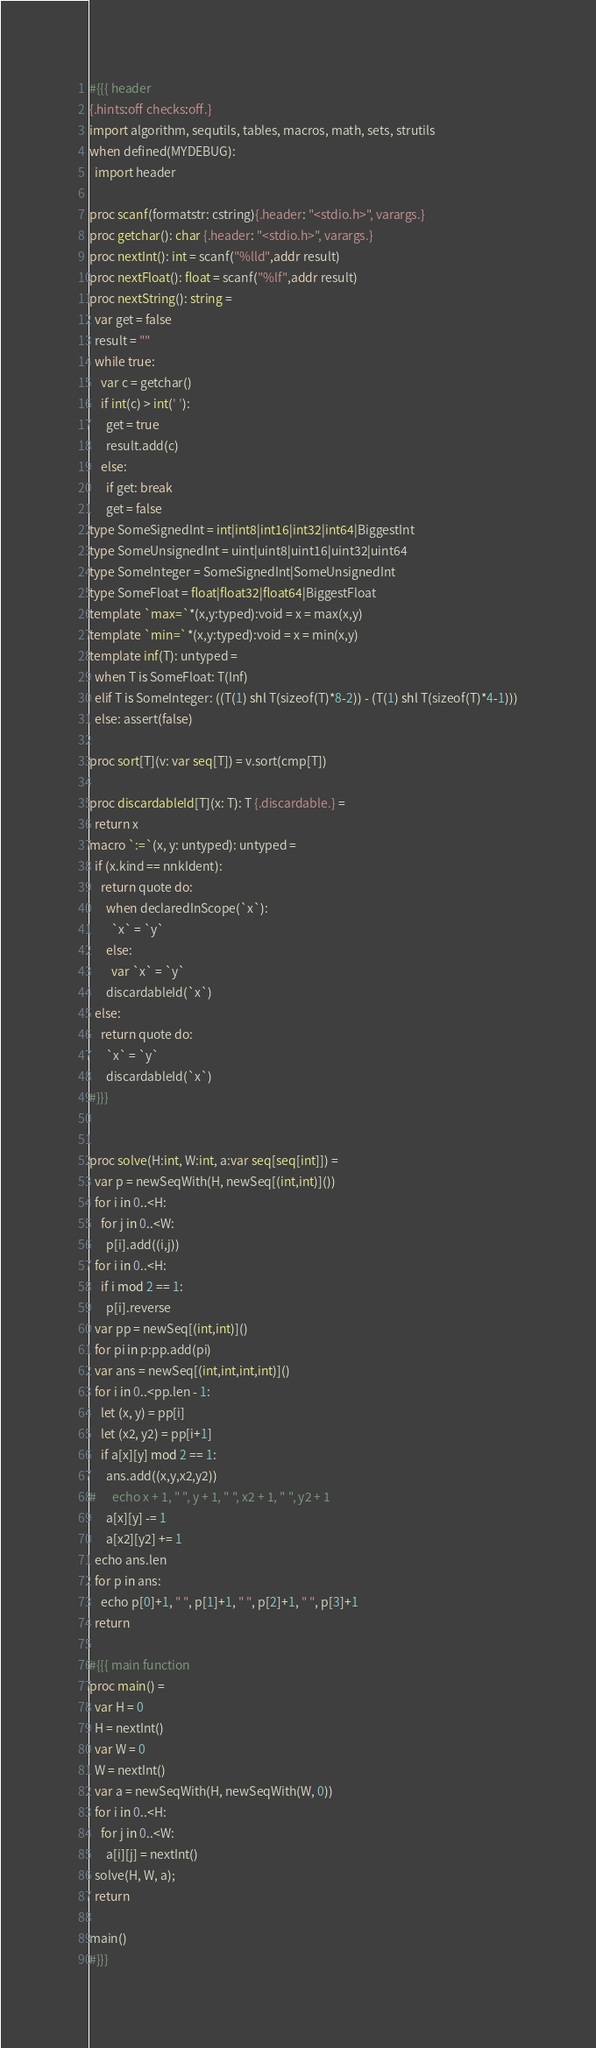Convert code to text. <code><loc_0><loc_0><loc_500><loc_500><_Nim_>#{{{ header
{.hints:off checks:off.}
import algorithm, sequtils, tables, macros, math, sets, strutils
when defined(MYDEBUG):
  import header

proc scanf(formatstr: cstring){.header: "<stdio.h>", varargs.}
proc getchar(): char {.header: "<stdio.h>", varargs.}
proc nextInt(): int = scanf("%lld",addr result)
proc nextFloat(): float = scanf("%lf",addr result)
proc nextString(): string =
  var get = false
  result = ""
  while true:
    var c = getchar()
    if int(c) > int(' '):
      get = true
      result.add(c)
    else:
      if get: break
      get = false
type SomeSignedInt = int|int8|int16|int32|int64|BiggestInt
type SomeUnsignedInt = uint|uint8|uint16|uint32|uint64
type SomeInteger = SomeSignedInt|SomeUnsignedInt
type SomeFloat = float|float32|float64|BiggestFloat
template `max=`*(x,y:typed):void = x = max(x,y)
template `min=`*(x,y:typed):void = x = min(x,y)
template inf(T): untyped = 
  when T is SomeFloat: T(Inf)
  elif T is SomeInteger: ((T(1) shl T(sizeof(T)*8-2)) - (T(1) shl T(sizeof(T)*4-1)))
  else: assert(false)

proc sort[T](v: var seq[T]) = v.sort(cmp[T])

proc discardableId[T](x: T): T {.discardable.} =
  return x
macro `:=`(x, y: untyped): untyped =
  if (x.kind == nnkIdent):
    return quote do:
      when declaredInScope(`x`):
        `x` = `y`
      else:
        var `x` = `y`
      discardableId(`x`)
  else:
    return quote do:
      `x` = `y`
      discardableId(`x`)
#}}}


proc solve(H:int, W:int, a:var seq[seq[int]]) =
  var p = newSeqWith(H, newSeq[(int,int)]())
  for i in 0..<H:
    for j in 0..<W:
      p[i].add((i,j))
  for i in 0..<H:
    if i mod 2 == 1:
      p[i].reverse
  var pp = newSeq[(int,int)]()
  for pi in p:pp.add(pi)
  var ans = newSeq[(int,int,int,int)]()
  for i in 0..<pp.len - 1:
    let (x, y) = pp[i]
    let (x2, y2) = pp[i+1]
    if a[x][y] mod 2 == 1:
      ans.add((x,y,x2,y2))
#      echo x + 1, " ", y + 1, " ", x2 + 1, " ", y2 + 1
      a[x][y] -= 1
      a[x2][y2] += 1
  echo ans.len
  for p in ans:
    echo p[0]+1, " ", p[1]+1, " ", p[2]+1, " ", p[3]+1
  return

#{{{ main function
proc main() =
  var H = 0
  H = nextInt()
  var W = 0
  W = nextInt()
  var a = newSeqWith(H, newSeqWith(W, 0))
  for i in 0..<H:
    for j in 0..<W:
      a[i][j] = nextInt()
  solve(H, W, a);
  return

main()
#}}}</code> 